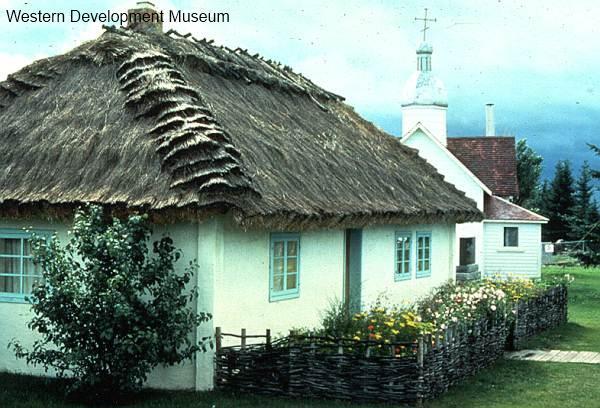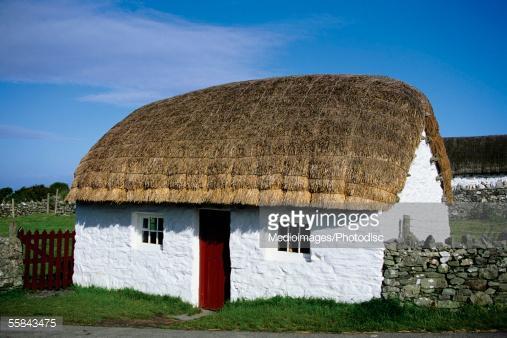The first image is the image on the left, the second image is the image on the right. Evaluate the accuracy of this statement regarding the images: "There are flowers by the house in one image, and a stone wall by the house in the other image.". Is it true? Answer yes or no. Yes. The first image is the image on the left, the second image is the image on the right. Assess this claim about the two images: "There is a small light brown building with a yellow straw looking roof free of any chimneys.". Correct or not? Answer yes or no. No. 